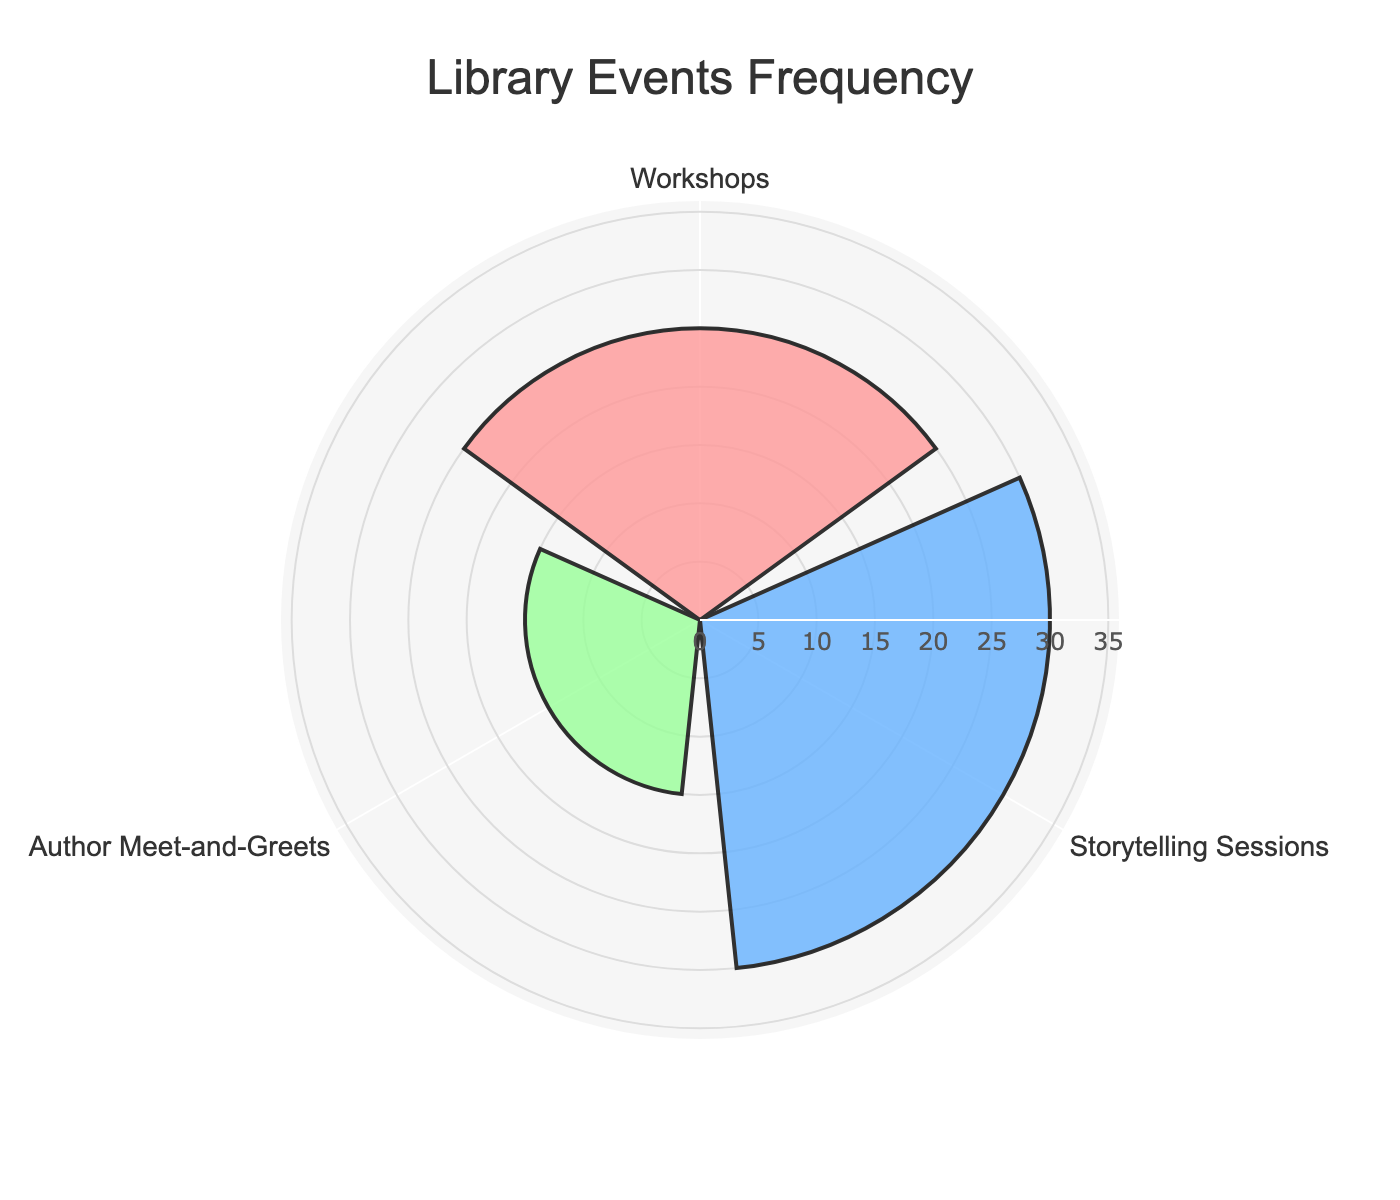What's the title of the chart? The title is displayed at the top of the chart, indicating the subject of the visualization.
Answer: Library Events Frequency What is the frequency of Author Meet-and-Greets? By looking for the segment labeled "Author Meet-and-Greets" and checking the value corresponding to it.
Answer: 15 Which event type has the highest frequency? Compare the frequencies of all event types and identify the highest value.
Answer: Storytelling Sessions How many times more frequent are Storytelling Sessions compared to Author Meet-and-Greets? Divide the frequency of Storytelling Sessions by the frequency of Author Meet-and-Greets. 30 ÷ 15 = 2
Answer: 2 What is the combined frequency of Workshops and Author Meet-and-Greets? Sum the frequencies of Workshops and Author Meet-and-Greets. 25 (Workshops) + 15 (Author Meet-and-Greets) = 40
Answer: 40 How much less frequent are Author Meet-and-Greets compared to Workshops? Subtract the frequency of Author Meet-and-Greets from the frequency of Workshops. 25 (Workshops) - 15 (Author Meet-and-Greets) = 10
Answer: 10 What's the range of frequencies displayed? Subtract the smallest frequency (Author Meet-and-Greets) from the largest frequency (Storytelling Sessions). 30 (Storytelling Sessions) - 15 (Author Meet-and-Greets) = 15
Answer: 15 Which event type is represented by the green color in the chart? Identify the event type associated with the green segment.
Answer: Author Meet-and-Greets What is the average frequency of the three event types? Sum the frequencies of all event types and divide by the number of event types. (25 + 30 + 15) ÷ 3 = 70 ÷ 3 = 23.33
Answer: 23.33 Is there an event type with a frequency greater than 20 but less than 30? Check all event types to see if any frequency falls within the specified range.
Answer: Workshops 